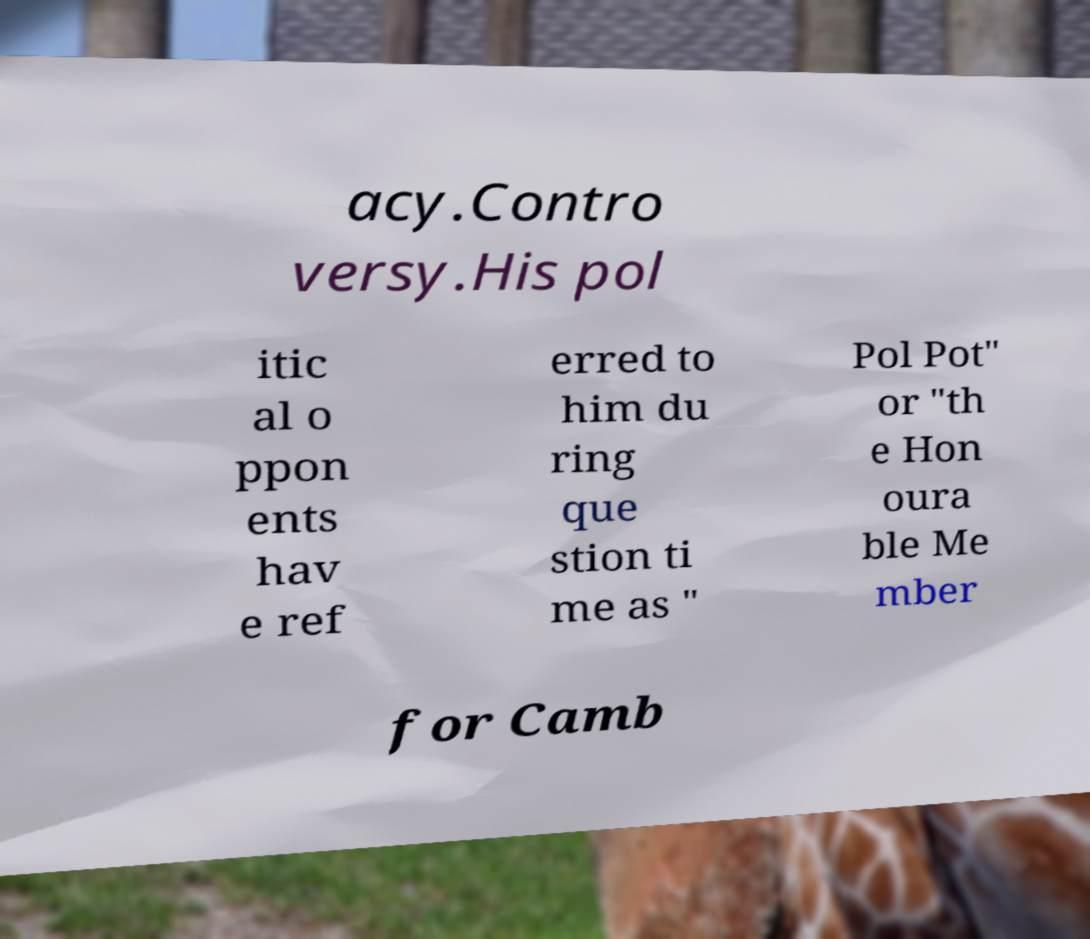What messages or text are displayed in this image? I need them in a readable, typed format. acy.Contro versy.His pol itic al o ppon ents hav e ref erred to him du ring que stion ti me as " Pol Pot" or "th e Hon oura ble Me mber for Camb 